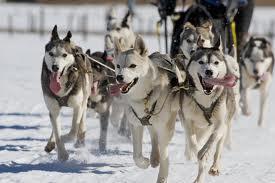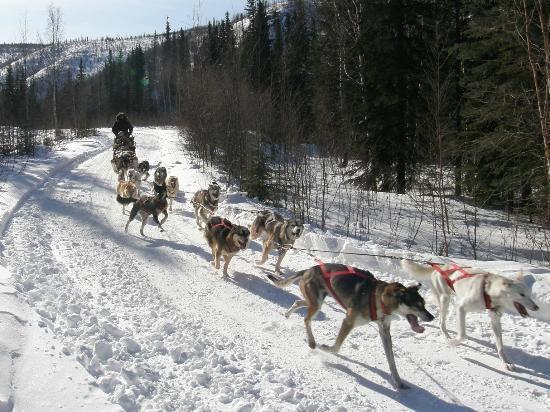The first image is the image on the left, the second image is the image on the right. Given the left and right images, does the statement "One image shows a dog team running forward toward the right, and the other image includes box-shaped doghouses along the horizon in front of evergreens and tall hills." hold true? Answer yes or no. No. The first image is the image on the left, the second image is the image on the right. Analyze the images presented: Is the assertion "In one image, sled dogs are standing at their base camp, and in the second image, they are running to pull a sled for a driver." valid? Answer yes or no. No. 